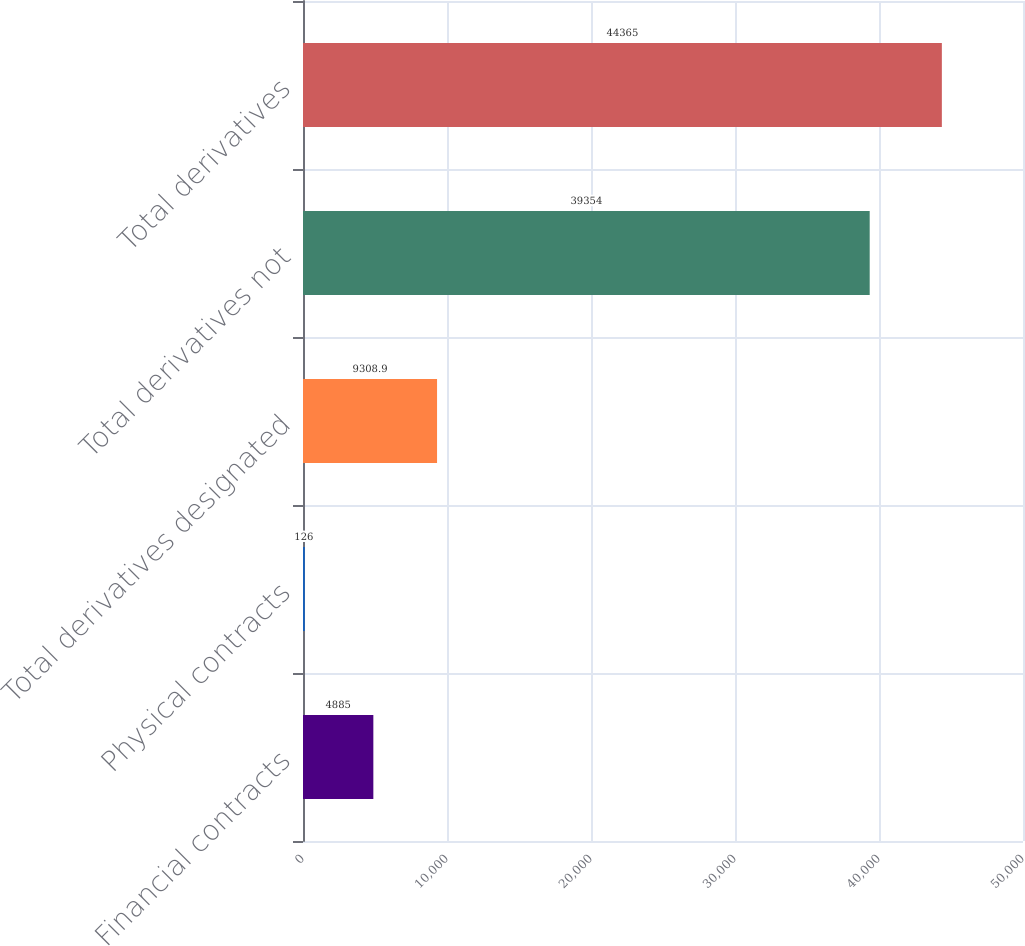<chart> <loc_0><loc_0><loc_500><loc_500><bar_chart><fcel>Financial contracts<fcel>Physical contracts<fcel>Total derivatives designated<fcel>Total derivatives not<fcel>Total derivatives<nl><fcel>4885<fcel>126<fcel>9308.9<fcel>39354<fcel>44365<nl></chart> 